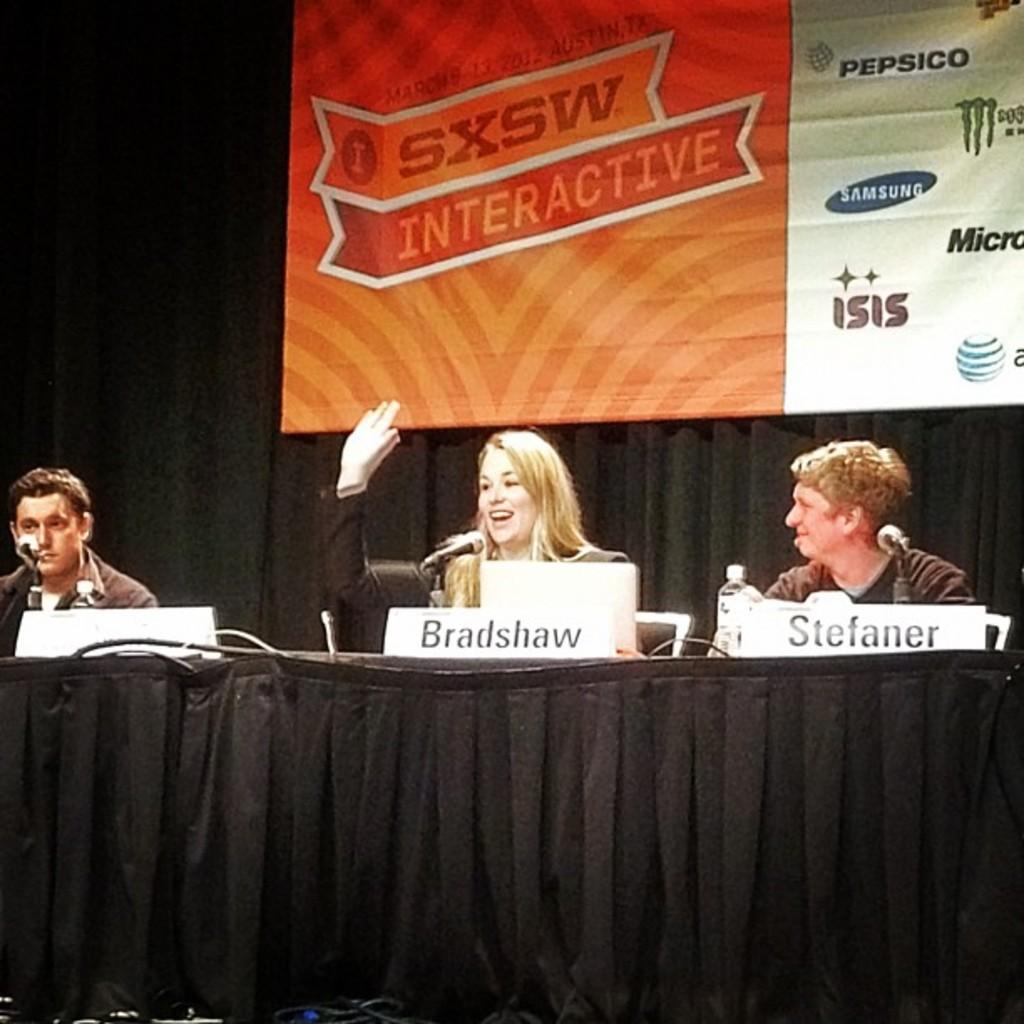How many people are seated in the image? There are three people seated in the image. What objects are in front of the people? Microphones are present in front of the people. What can be seen behind the people in the image? There is a hoarding visible behind the people. What is the condition of the home in the image? There is no home present in the image; it features three people seated with microphones in front of them and a hoarding in the background. 